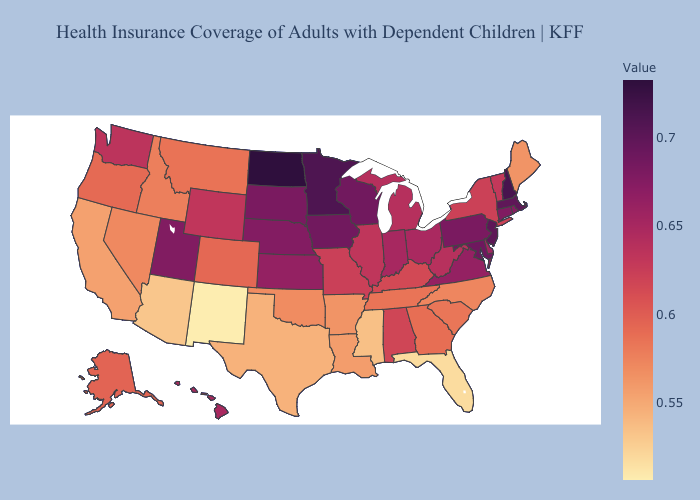Does New Hampshire have the highest value in the USA?
Answer briefly. No. Does Colorado have a higher value than Massachusetts?
Short answer required. No. Does Illinois have the lowest value in the MidWest?
Be succinct. No. Does Hawaii have a lower value than South Dakota?
Write a very short answer. Yes. 